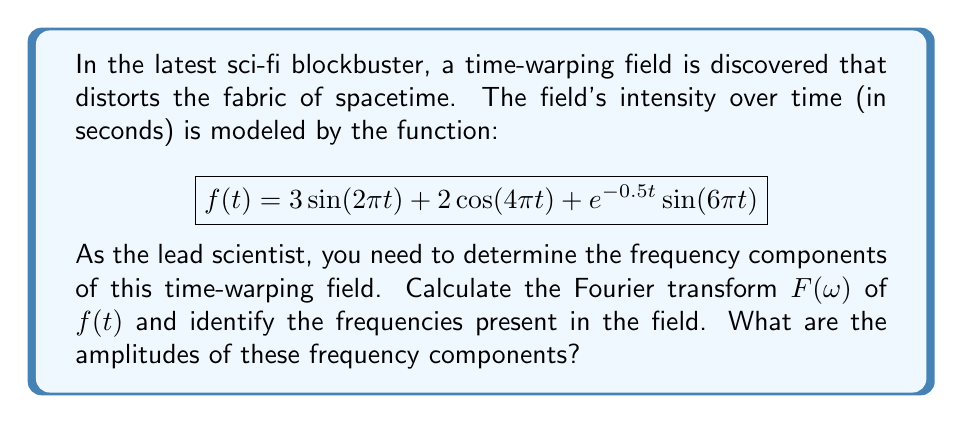Show me your answer to this math problem. To solve this problem, we need to apply the Fourier transform to the given function $f(t)$. The Fourier transform of a function $f(t)$ is defined as:

$$F(\omega) = \int_{-\infty}^{\infty} f(t) e^{-i\omega t} dt$$

Let's break down $f(t)$ into its components and analyze each:

1. $3\sin(2\pi t)$:
   The Fourier transform of $\sin(\omega_0 t)$ is:
   $$\mathcal{F}\{\sin(\omega_0 t)\} = \frac{i}{2}[\delta(\omega + \omega_0) - \delta(\omega - \omega_0)]$$
   So, $\mathcal{F}\{3\sin(2\pi t)\} = \frac{3i}{2}[\delta(\omega + 2\pi) - \delta(\omega - 2\pi)]$

2. $2\cos(4\pi t)$:
   The Fourier transform of $\cos(\omega_0 t)$ is:
   $$\mathcal{F}\{\cos(\omega_0 t)\} = \frac{1}{2}[\delta(\omega + \omega_0) + \delta(\omega - \omega_0)]$$
   So, $\mathcal{F}\{2\cos(4\pi t)\} = [\delta(\omega + 4\pi) + \delta(\omega - 4\pi)]$

3. $e^{-0.5t}\sin(6\pi t)$:
   This is more complex. The Fourier transform of $e^{-at}\sin(\omega_0 t)$ for $a > 0$ is:
   $$\mathcal{F}\{e^{-at}\sin(\omega_0 t)\} = \frac{\omega_0}{(\omega - \omega_0)^2 + a^2} - \frac{\omega_0}{(\omega + \omega_0)^2 + a^2}$$
   Here, $a = 0.5$ and $\omega_0 = 6\pi$, so:
   $$\mathcal{F}\{e^{-0.5t}\sin(6\pi t)\} = \frac{6\pi}{(\omega - 6\pi)^2 + 0.25} - \frac{6\pi}{(\omega + 6\pi)^2 + 0.25}$$

Combining these results, we get the Fourier transform $F(\omega)$:

$$F(\omega) = \frac{3i}{2}[\delta(\omega + 2\pi) - \delta(\omega - 2\pi)] + [\delta(\omega + 4\pi) + \delta(\omega - 4\pi)] + \frac{6\pi}{(\omega - 6\pi)^2 + 0.25} - \frac{6\pi}{(\omega + 6\pi)^2 + 0.25}$$

From this, we can identify the frequency components:

1. $\omega = \pm 2\pi$ (1 Hz) with amplitude 3
2. $\omega = \pm 4\pi$ (2 Hz) with amplitude 2
3. A broadband component centered at $\omega = \pm 6\pi$ (3 Hz) with a peak amplitude of 24π
Answer: The time-warping field contains three main frequency components:
1. 1 Hz with amplitude 3
2. 2 Hz with amplitude 2
3. 3 Hz (broadband) with peak amplitude 24π 